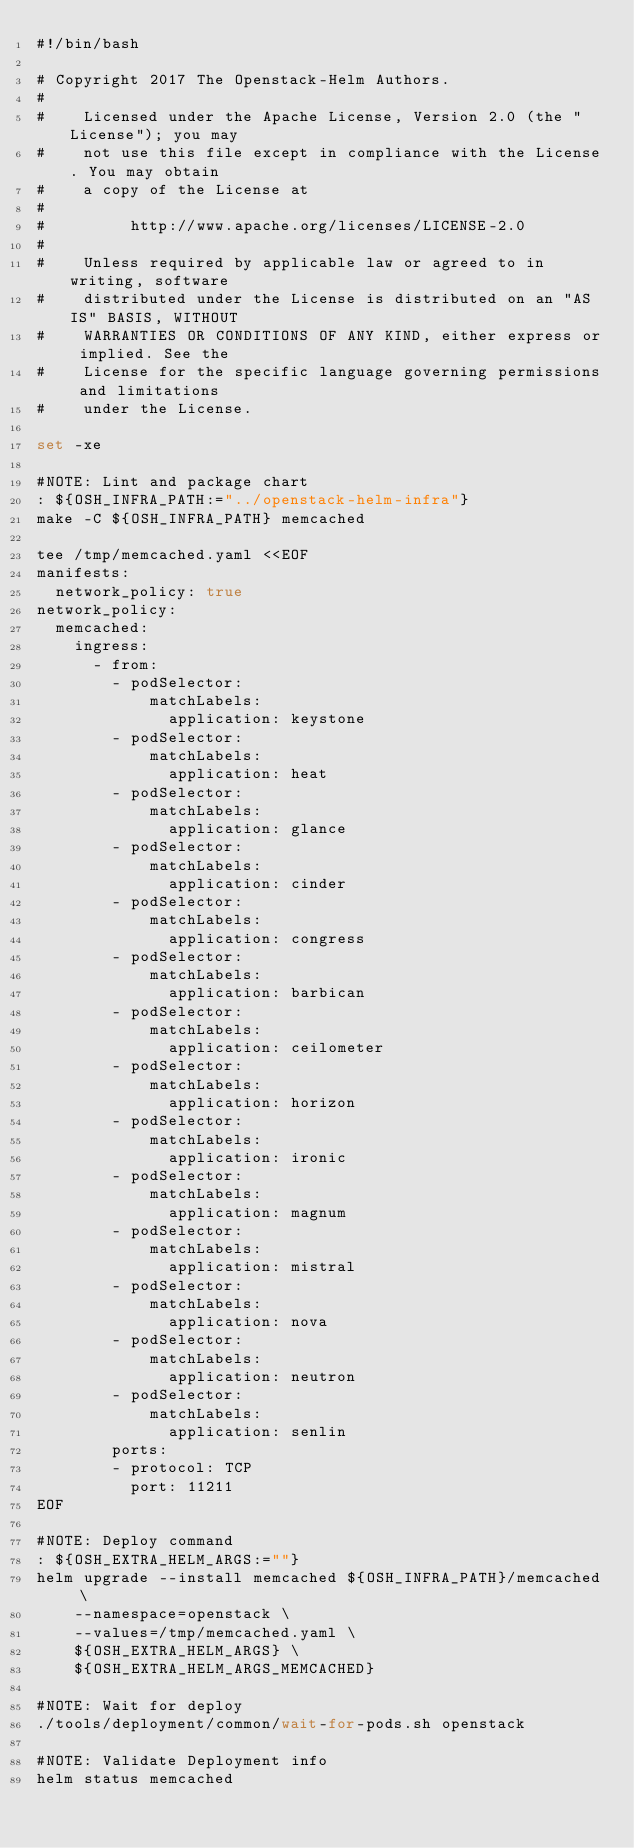<code> <loc_0><loc_0><loc_500><loc_500><_Bash_>#!/bin/bash

# Copyright 2017 The Openstack-Helm Authors.
#
#    Licensed under the Apache License, Version 2.0 (the "License"); you may
#    not use this file except in compliance with the License. You may obtain
#    a copy of the License at
#
#         http://www.apache.org/licenses/LICENSE-2.0
#
#    Unless required by applicable law or agreed to in writing, software
#    distributed under the License is distributed on an "AS IS" BASIS, WITHOUT
#    WARRANTIES OR CONDITIONS OF ANY KIND, either express or implied. See the
#    License for the specific language governing permissions and limitations
#    under the License.

set -xe

#NOTE: Lint and package chart
: ${OSH_INFRA_PATH:="../openstack-helm-infra"}
make -C ${OSH_INFRA_PATH} memcached

tee /tmp/memcached.yaml <<EOF
manifests:
  network_policy: true
network_policy:
  memcached:
    ingress:
      - from:
        - podSelector:
            matchLabels:
              application: keystone
        - podSelector:
            matchLabels:
              application: heat
        - podSelector:
            matchLabels:
              application: glance
        - podSelector:
            matchLabels:
              application: cinder
        - podSelector:
            matchLabels:
              application: congress
        - podSelector:
            matchLabels:
              application: barbican
        - podSelector:
            matchLabels:
              application: ceilometer
        - podSelector:
            matchLabels:
              application: horizon
        - podSelector:
            matchLabels:
              application: ironic
        - podSelector:
            matchLabels:
              application: magnum
        - podSelector:
            matchLabels:
              application: mistral
        - podSelector:
            matchLabels:
              application: nova
        - podSelector:
            matchLabels:
              application: neutron
        - podSelector:
            matchLabels:
              application: senlin
        ports:
        - protocol: TCP
          port: 11211
EOF

#NOTE: Deploy command
: ${OSH_EXTRA_HELM_ARGS:=""}
helm upgrade --install memcached ${OSH_INFRA_PATH}/memcached \
    --namespace=openstack \
    --values=/tmp/memcached.yaml \
    ${OSH_EXTRA_HELM_ARGS} \
    ${OSH_EXTRA_HELM_ARGS_MEMCACHED}

#NOTE: Wait for deploy
./tools/deployment/common/wait-for-pods.sh openstack

#NOTE: Validate Deployment info
helm status memcached
</code> 